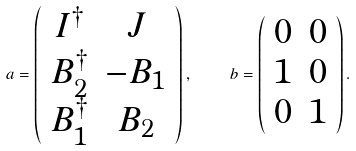Convert formula to latex. <formula><loc_0><loc_0><loc_500><loc_500>a = \left ( \begin{array} { c c } I ^ { \dag } & J \\ B _ { 2 } ^ { \dagger } & - B _ { 1 } \\ B _ { 1 } ^ { \dagger } & B _ { 2 } \end{array} \right ) , \quad b = \left ( \begin{array} { c c } 0 & 0 \\ 1 & 0 \\ 0 & 1 \end{array} \right ) .</formula> 